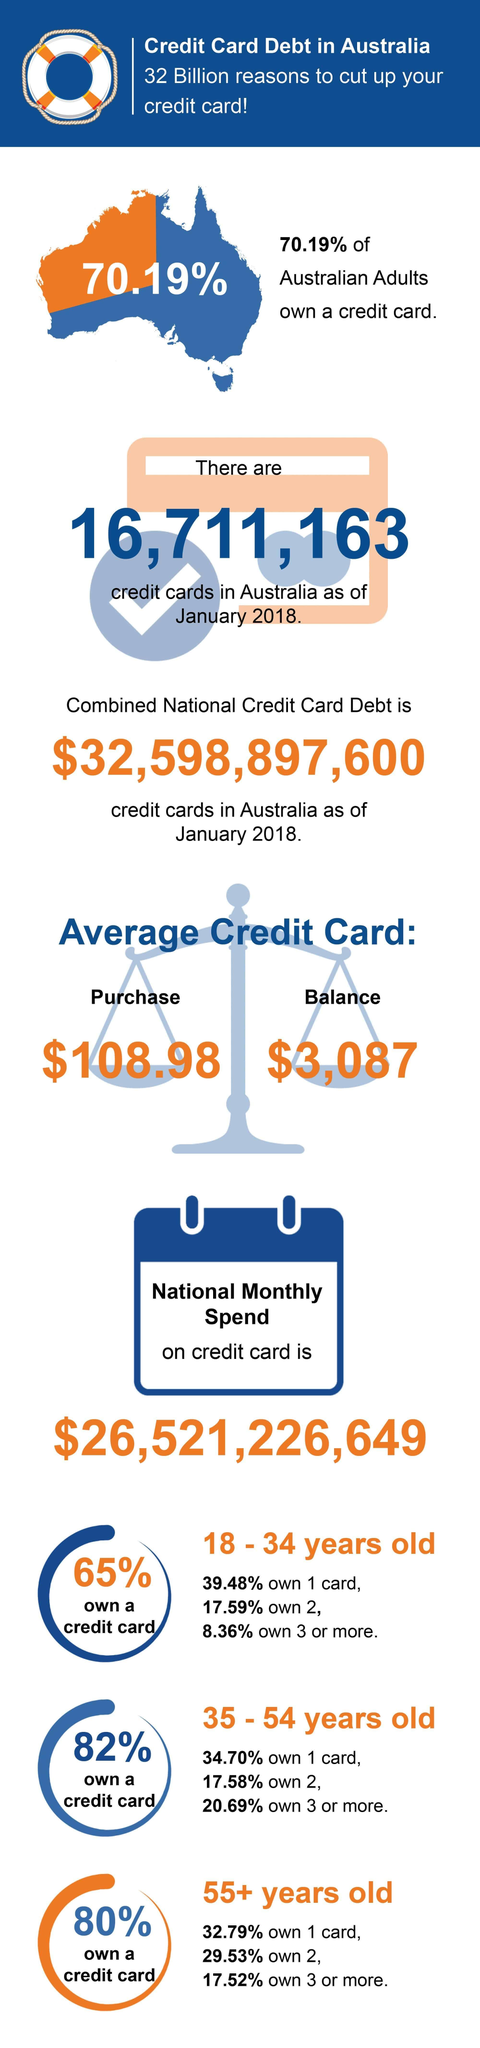What is the average credit card balance in Australia as of January 2018?
Answer the question with a short phrase. $3,087 What percentage of Australians in the age group of 35-54 years do not own a credit card? 18% What percentage of Australians in the age group of 55+ years do not own a credit card? 20% What percentage of Australians in the age group of 18-34 years do not own a credit card? 35% What percentage of Australians do not own a credit card as of January 2018? 29.81% 